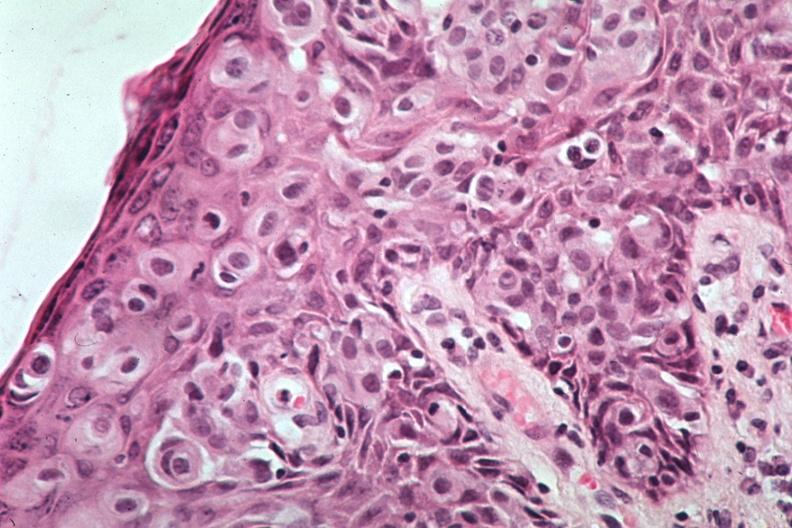s this image a quite excellent example of pagets disease?
Answer the question using a single word or phrase. Yes 